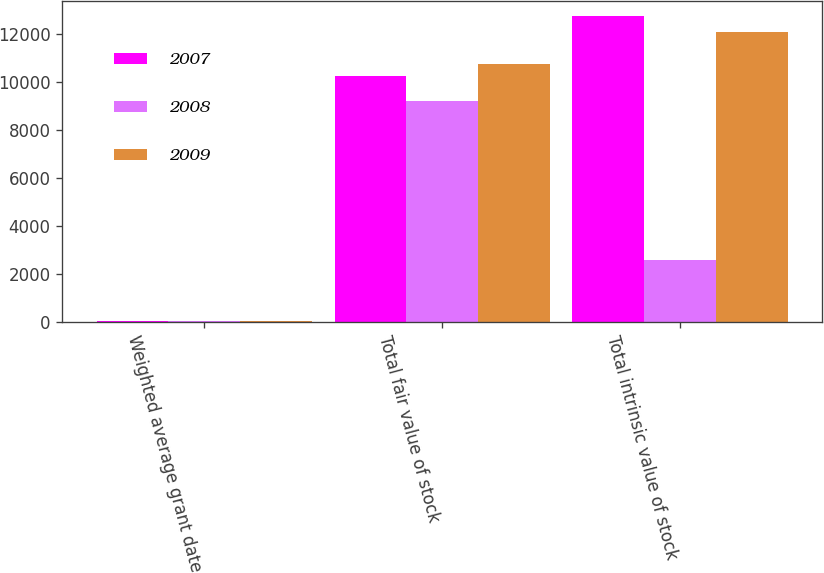Convert chart to OTSL. <chart><loc_0><loc_0><loc_500><loc_500><stacked_bar_chart><ecel><fcel>Weighted average grant date<fcel>Total fair value of stock<fcel>Total intrinsic value of stock<nl><fcel>2007<fcel>12.96<fcel>10225<fcel>12742<nl><fcel>2008<fcel>14.54<fcel>9192<fcel>2561<nl><fcel>2009<fcel>16.15<fcel>10748<fcel>12075<nl></chart> 